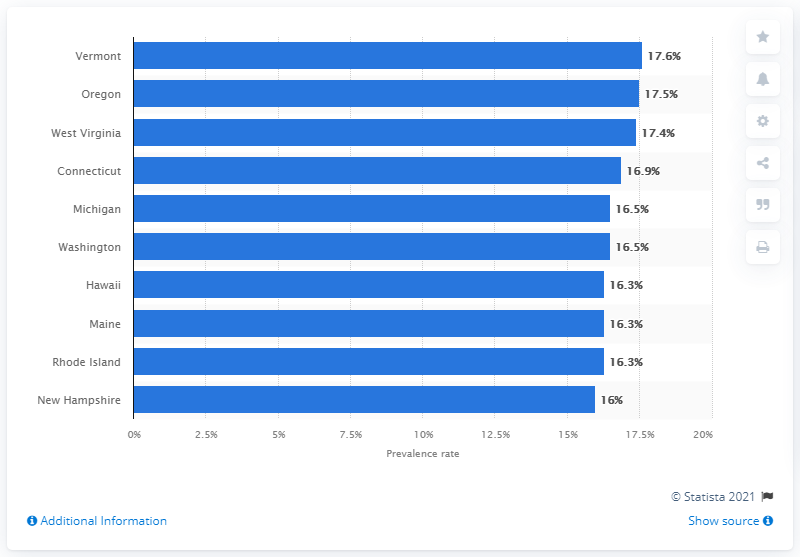Outline some significant characteristics in this image. The highest lifetime prevalence of asthma among adults in Vermont in 2019 was 17.6%. In 2019, the highest lifetime prevalence of asthma among adults in Vermont was 17.6%. 